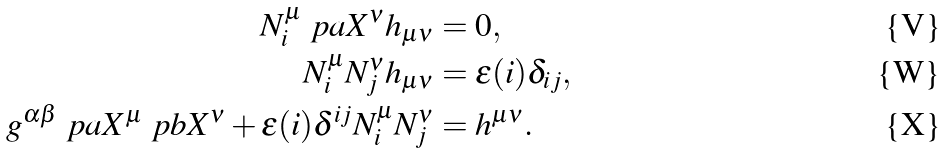<formula> <loc_0><loc_0><loc_500><loc_500>N _ { i } ^ { \mu } \ p a X ^ { \nu } h _ { \mu \nu } & = 0 , \\ N _ { i } ^ { \mu } N _ { j } ^ { \nu } h _ { \mu \nu } & = \epsilon ( i ) \delta _ { i j } , \\ g ^ { \alpha \beta } \ p a X ^ { \mu } \ p b X ^ { \nu } + \epsilon ( i ) \delta ^ { i j } N _ { i } ^ { \mu } N _ { j } ^ { \nu } & = h ^ { \mu \nu } .</formula> 